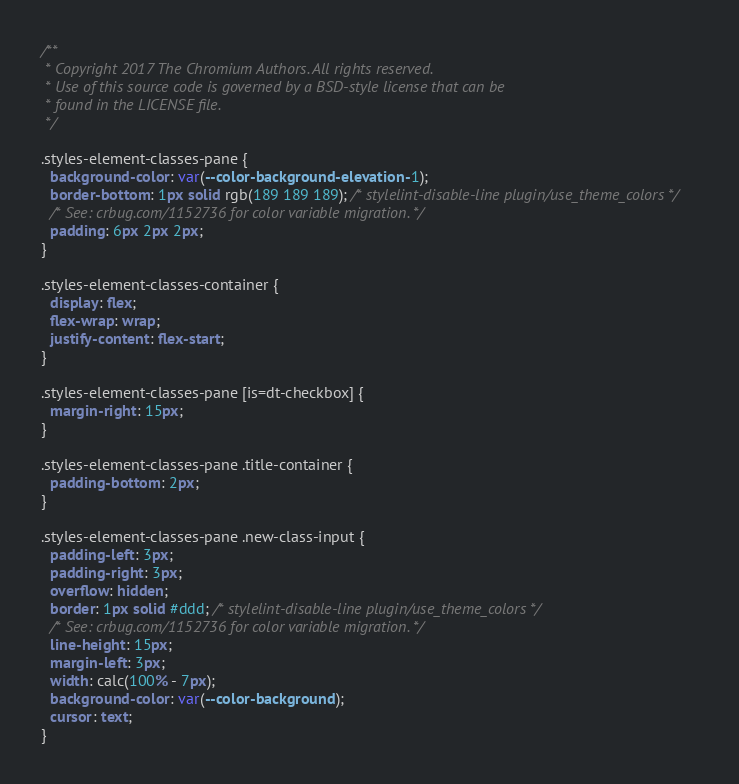<code> <loc_0><loc_0><loc_500><loc_500><_CSS_>/**
 * Copyright 2017 The Chromium Authors. All rights reserved.
 * Use of this source code is governed by a BSD-style license that can be
 * found in the LICENSE file.
 */

.styles-element-classes-pane {
  background-color: var(--color-background-elevation-1);
  border-bottom: 1px solid rgb(189 189 189); /* stylelint-disable-line plugin/use_theme_colors */
  /* See: crbug.com/1152736 for color variable migration. */
  padding: 6px 2px 2px;
}

.styles-element-classes-container {
  display: flex;
  flex-wrap: wrap;
  justify-content: flex-start;
}

.styles-element-classes-pane [is=dt-checkbox] {
  margin-right: 15px;
}

.styles-element-classes-pane .title-container {
  padding-bottom: 2px;
}

.styles-element-classes-pane .new-class-input {
  padding-left: 3px;
  padding-right: 3px;
  overflow: hidden;
  border: 1px solid #ddd; /* stylelint-disable-line plugin/use_theme_colors */
  /* See: crbug.com/1152736 for color variable migration. */
  line-height: 15px;
  margin-left: 3px;
  width: calc(100% - 7px);
  background-color: var(--color-background);
  cursor: text;
}
</code> 